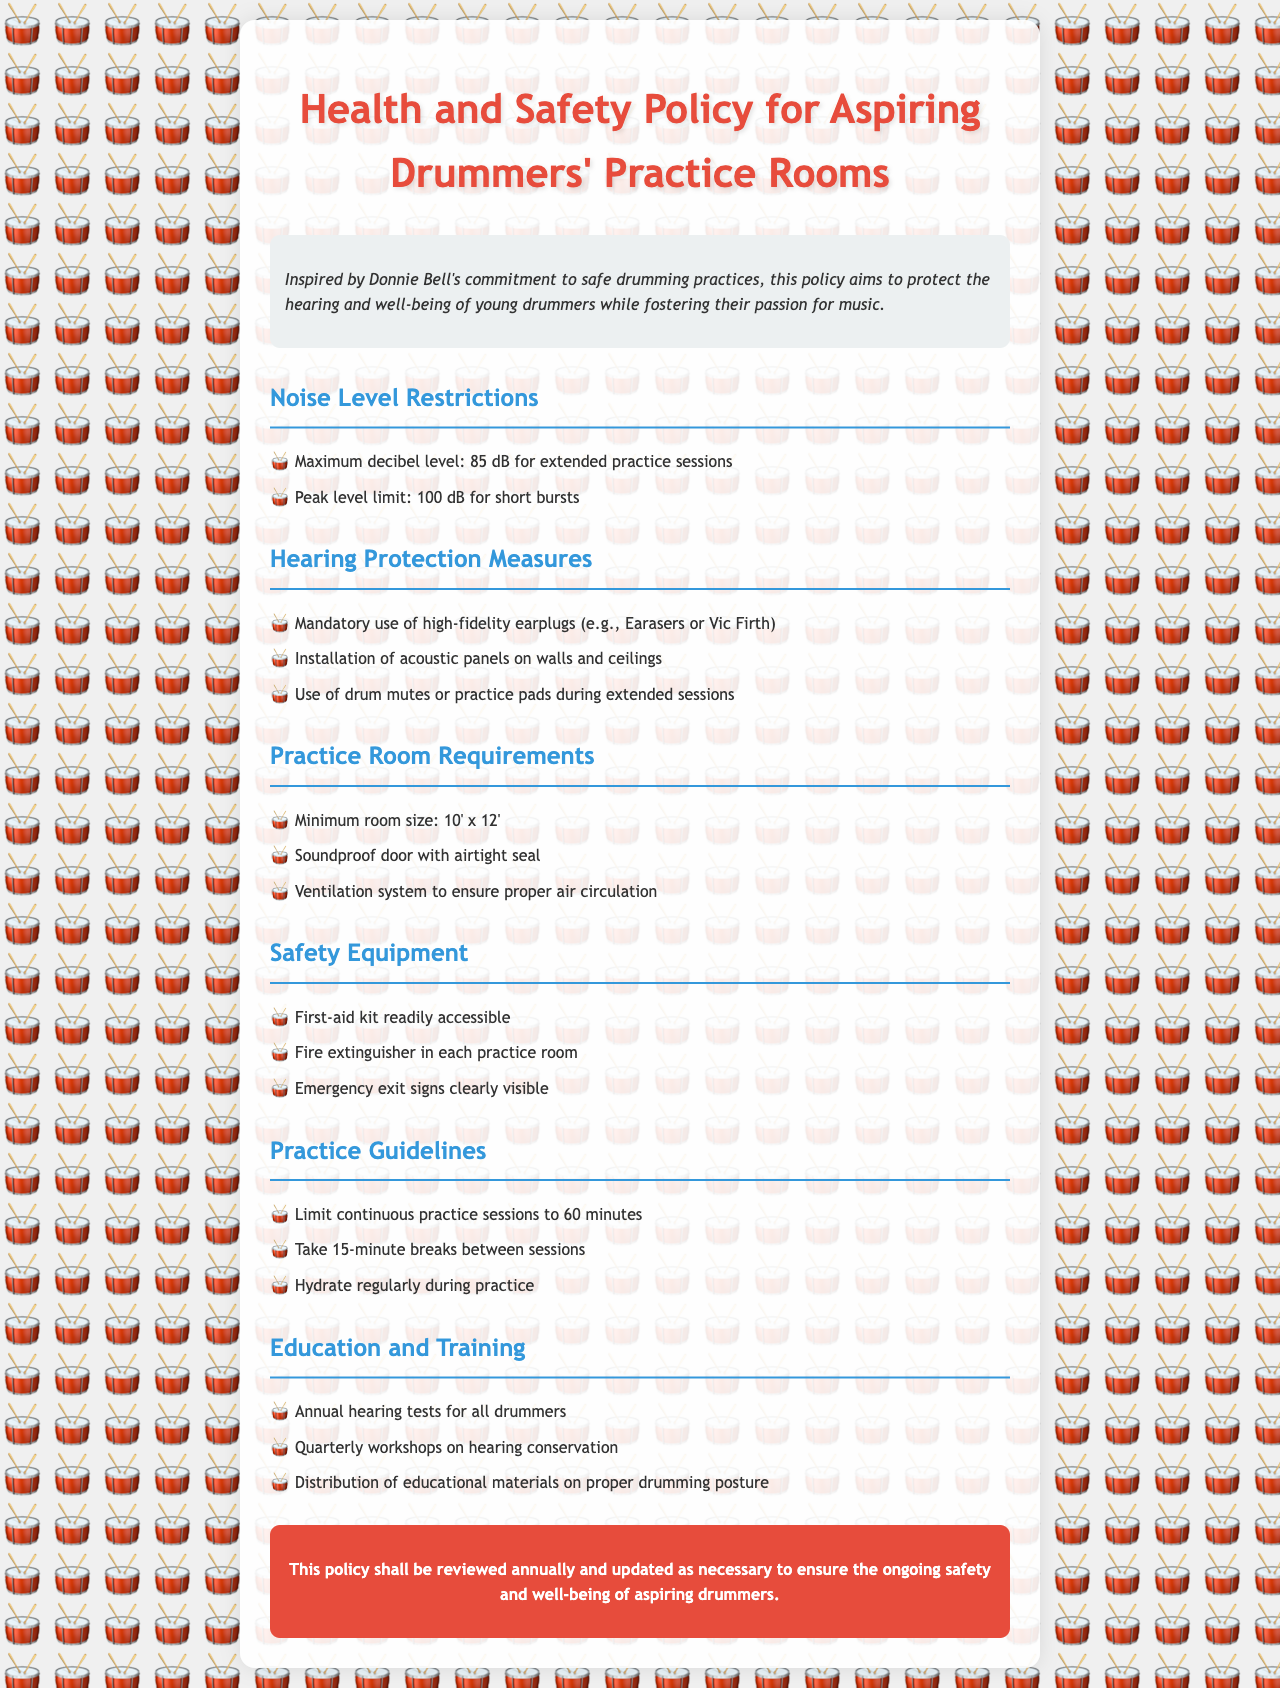What is the maximum decibel level for extended practice sessions? The maximum decibel level for extended practice sessions is explicitly stated in the document as 85 dB.
Answer: 85 dB What type of earplugs is mandatory? The policy specifically mentions the mandatory use of high-fidelity earplugs such as Earasers or Vic Firth.
Answer: High-fidelity earplugs What is the minimum room size specified? The policy outlines a minimum room size requirement, which is 10 feet by 12 feet.
Answer: 10' x 12' How often are hearing tests required? The document states that annual hearing tests are required for all drummers.
Answer: Annual What is the limit for continuous practice sessions? A limit for continuous practice sessions is established in the document, specifically to 60 minutes.
Answer: 60 minutes What must be installed on the walls and ceilings? The document states that acoustic panels must be installed on the walls and ceilings.
Answer: Acoustic panels What is the peak level limit for short bursts? The document mentions that the peak level limit for short bursts is 100 dB.
Answer: 100 dB How frequently are workshops on hearing conservation held? The document specifies that quarterly workshops on hearing conservation will take place.
Answer: Quarterly What is the purpose of a first-aid kit? The document implies that a first-aid kit is readily accessible to ensure safety during drum practice.
Answer: Safety 